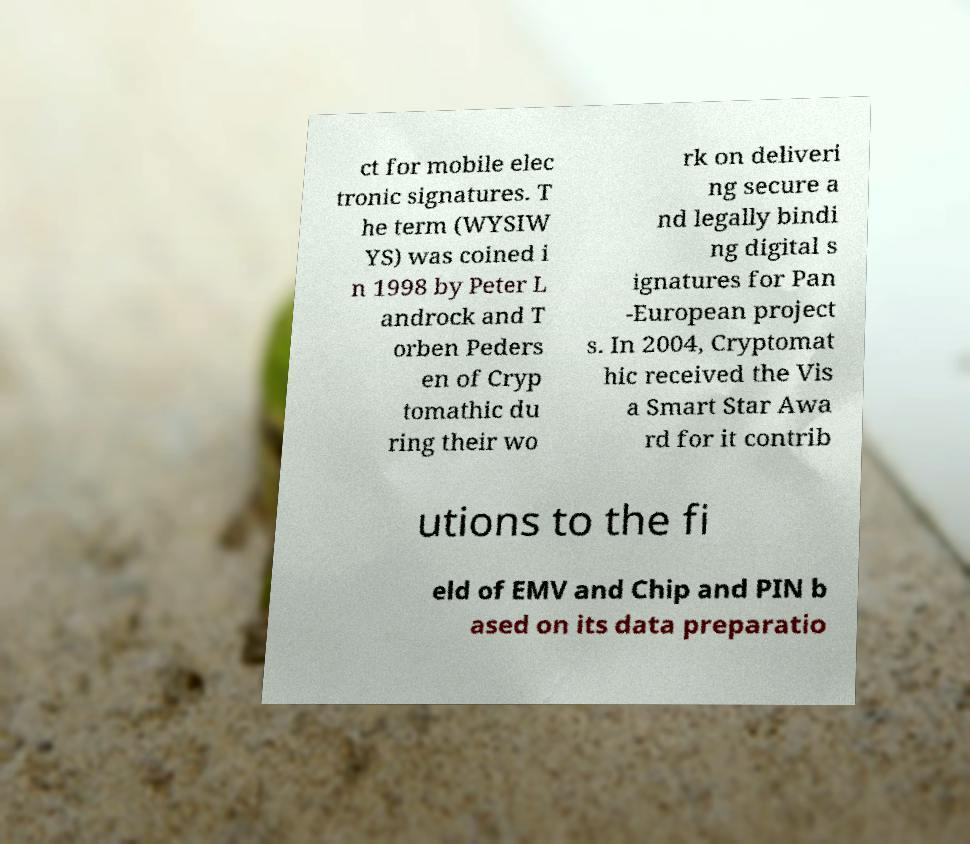Please read and relay the text visible in this image. What does it say? ct for mobile elec tronic signatures. T he term (WYSIW YS) was coined i n 1998 by Peter L androck and T orben Peders en of Cryp tomathic du ring their wo rk on deliveri ng secure a nd legally bindi ng digital s ignatures for Pan -European project s. In 2004, Cryptomat hic received the Vis a Smart Star Awa rd for it contrib utions to the fi eld of EMV and Chip and PIN b ased on its data preparatio 